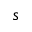Convert formula to latex. <formula><loc_0><loc_0><loc_500><loc_500>s</formula> 